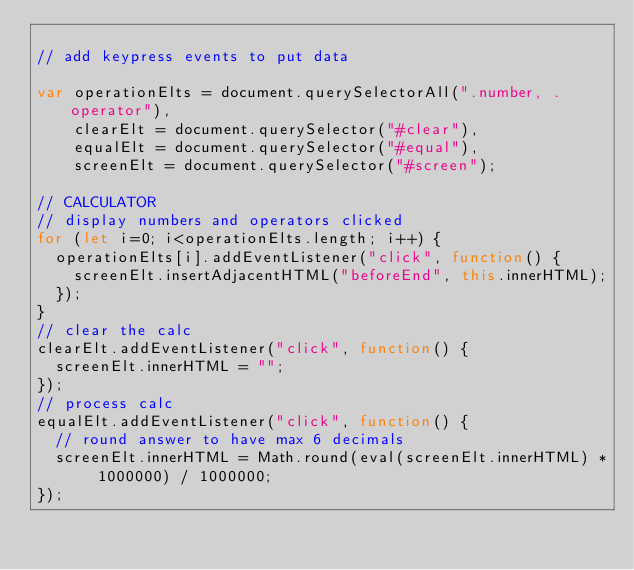Convert code to text. <code><loc_0><loc_0><loc_500><loc_500><_JavaScript_>
// add keypress events to put data

var operationElts = document.querySelectorAll(".number, .operator"),
    clearElt = document.querySelector("#clear"),
    equalElt = document.querySelector("#equal"),
    screenElt = document.querySelector("#screen");

// CALCULATOR
// display numbers and operators clicked
for (let i=0; i<operationElts.length; i++) {
  operationElts[i].addEventListener("click", function() {
    screenElt.insertAdjacentHTML("beforeEnd", this.innerHTML);
  });
}
// clear the calc
clearElt.addEventListener("click", function() {
  screenElt.innerHTML = "";
});
// process calc
equalElt.addEventListener("click", function() {
  // round answer to have max 6 decimals
  screenElt.innerHTML = Math.round(eval(screenElt.innerHTML) * 1000000) / 1000000;
});</code> 